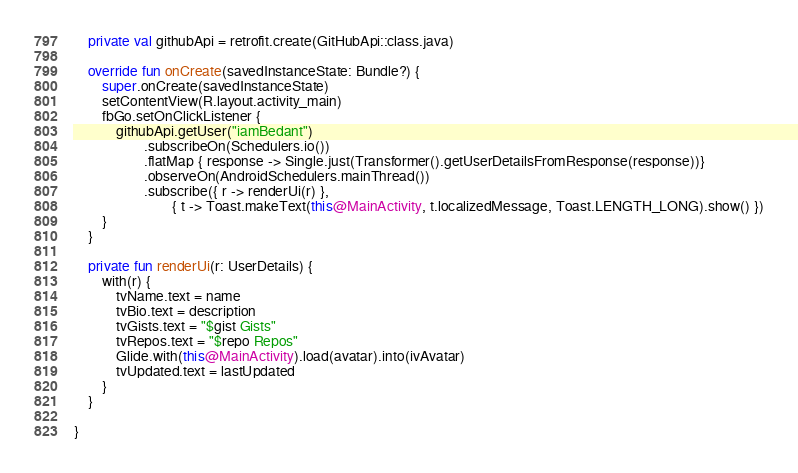<code> <loc_0><loc_0><loc_500><loc_500><_Kotlin_>
    private val githubApi = retrofit.create(GitHubApi::class.java)

    override fun onCreate(savedInstanceState: Bundle?) {
        super.onCreate(savedInstanceState)
        setContentView(R.layout.activity_main)
        fbGo.setOnClickListener {
            githubApi.getUser("iamBedant")
                    .subscribeOn(Schedulers.io())
                    .flatMap { response -> Single.just(Transformer().getUserDetailsFromResponse(response))}
                    .observeOn(AndroidSchedulers.mainThread())
                    .subscribe({ r -> renderUi(r) },
                            { t -> Toast.makeText(this@MainActivity, t.localizedMessage, Toast.LENGTH_LONG).show() })
        }
    }

    private fun renderUi(r: UserDetails) {
        with(r) {
            tvName.text = name
            tvBio.text = description
            tvGists.text = "$gist Gists"
            tvRepos.text = "$repo Repos"
            Glide.with(this@MainActivity).load(avatar).into(ivAvatar)
            tvUpdated.text = lastUpdated
        }
    }

}
</code> 